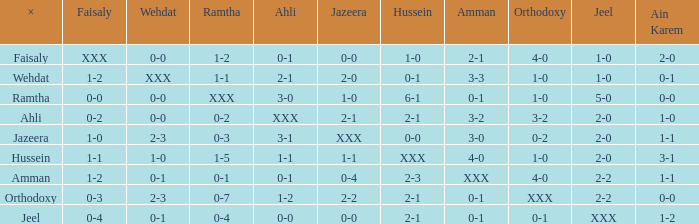What is faisaly when wehdat is xxx? 1-2. Would you be able to parse every entry in this table? {'header': ['×', 'Faisaly', 'Wehdat', 'Ramtha', 'Ahli', 'Jazeera', 'Hussein', 'Amman', 'Orthodoxy', 'Jeel', 'Ain Karem'], 'rows': [['Faisaly', 'XXX', '0-0', '1-2', '0-1', '0-0', '1-0', '2-1', '4-0', '1-0', '2-0'], ['Wehdat', '1-2', 'XXX', '1-1', '2-1', '2-0', '0-1', '3-3', '1-0', '1-0', '0-1'], ['Ramtha', '0-0', '0-0', 'XXX', '3-0', '1-0', '6-1', '0-1', '1-0', '5-0', '0-0'], ['Ahli', '0-2', '0-0', '0-2', 'XXX', '2-1', '2-1', '3-2', '3-2', '2-0', '1-0'], ['Jazeera', '1-0', '2-3', '0-3', '3-1', 'XXX', '0-0', '3-0', '0-2', '2-0', '1-1'], ['Hussein', '1-1', '1-0', '1-5', '1-1', '1-1', 'XXX', '4-0', '1-0', '2-0', '3-1'], ['Amman', '1-2', '0-1', '0-1', '0-1', '0-4', '2-3', 'XXX', '4-0', '2-2', '1-1'], ['Orthodoxy', '0-3', '2-3', '0-7', '1-2', '2-2', '2-1', '0-1', 'XXX', '2-2', '0-0'], ['Jeel', '0-4', '0-1', '0-4', '0-0', '0-0', '2-1', '0-1', '0-1', 'XXX', '1-2']]} 